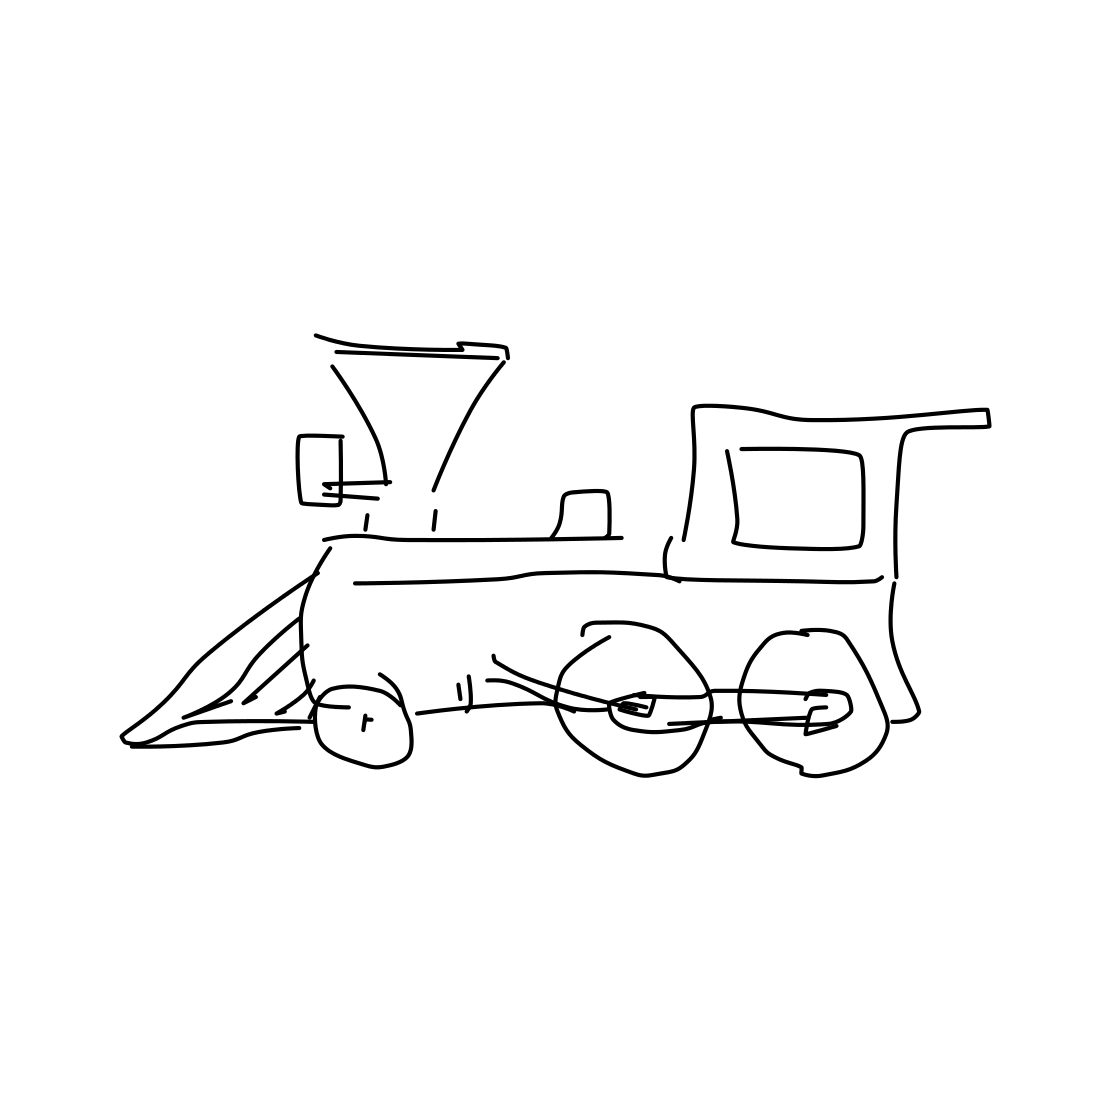What era does the train design in this image appear to be from? The train design with its large steam locomotive and certain classic features suggests it's reminiscent of the early to mid-19th century, a period known for the rapid development of railway technology. 